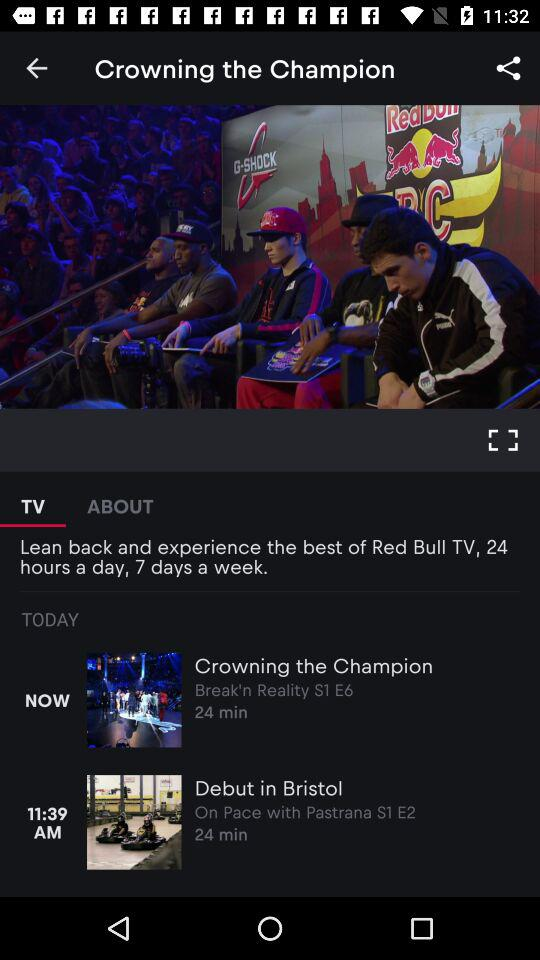What is the video length of "Debut in Bristol"? The video length is 24 minutes. 